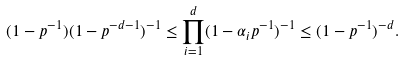Convert formula to latex. <formula><loc_0><loc_0><loc_500><loc_500>( 1 - p ^ { - 1 } ) ( 1 - p ^ { - d - 1 } ) ^ { - 1 } \leq \prod _ { i = 1 } ^ { d } ( 1 - \alpha _ { i } p ^ { - 1 } ) ^ { - 1 } \leq ( 1 - p ^ { - 1 } ) ^ { - d } .</formula> 